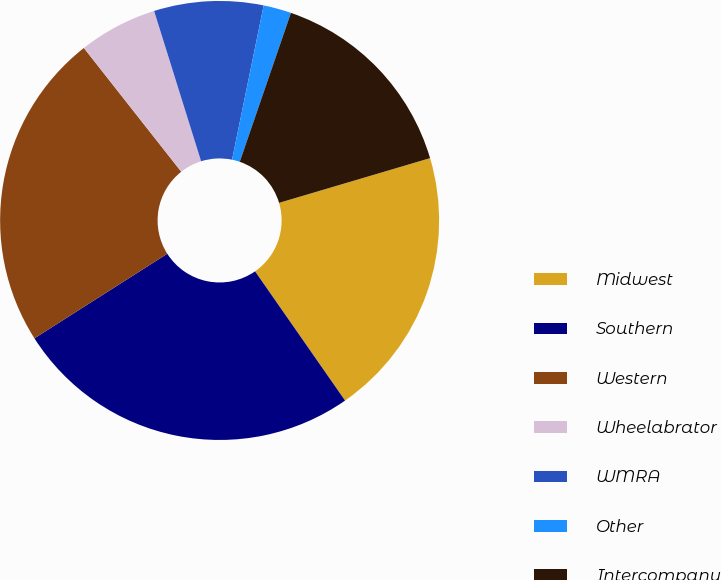Convert chart to OTSL. <chart><loc_0><loc_0><loc_500><loc_500><pie_chart><fcel>Midwest<fcel>Southern<fcel>Western<fcel>Wheelabrator<fcel>WMRA<fcel>Other<fcel>Intercompany<nl><fcel>19.9%<fcel>25.66%<fcel>23.41%<fcel>5.79%<fcel>8.04%<fcel>2.05%<fcel>15.15%<nl></chart> 